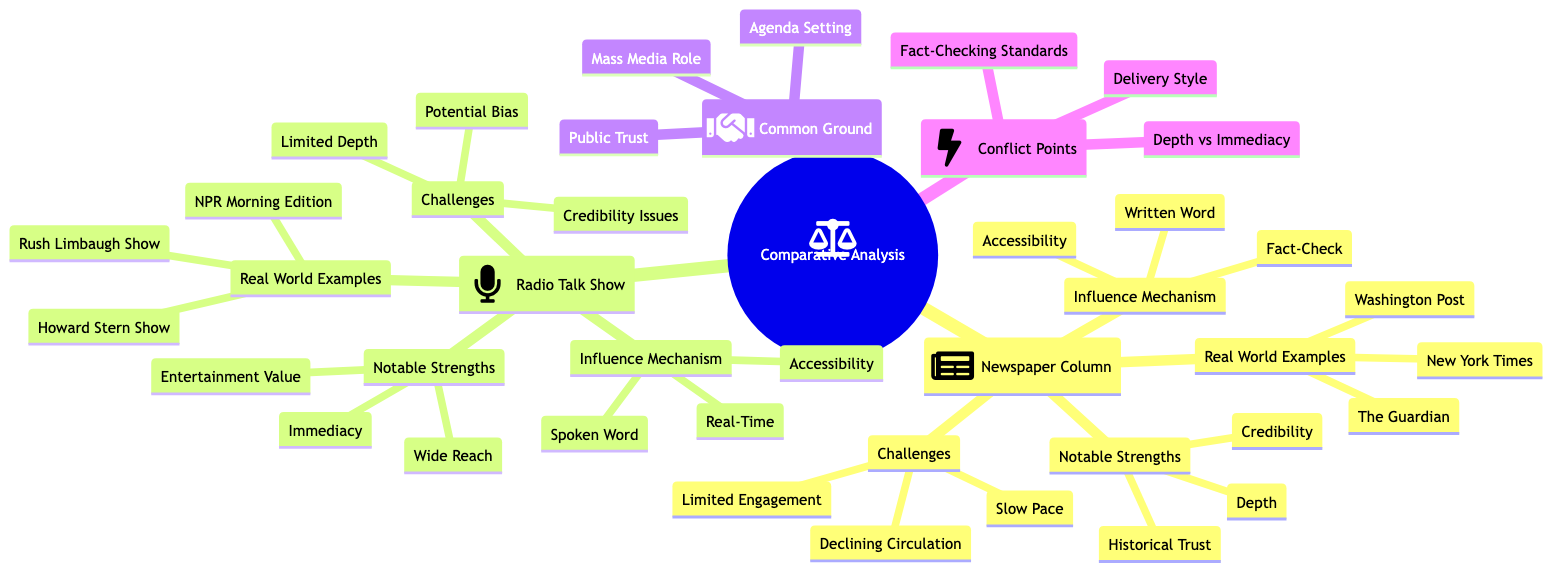What are the notable strengths of the Newspaper Column? The diagram lists three notable strengths under the Newspaper Column section: Depth, Credibility, and Historical Trust.
Answer: Depth, Credibility, Historical Trust Which radio talk show is mentioned as influential in shaping conservative public opinion? The diagram specifically identifies the Rush Limbaugh Show as influential in shaping conservative public opinion under the Real World Examples for Radio Talk Show.
Answer: Rush Limbaugh Show What is a common ground shared by both media forms? The diagram includes three points under Common Ground, one of which is Public Trust, showing that both media rely on maintaining or building public trust.
Answer: Public Trust How does the influence mechanism of the Newspaper Column compare to that of the Radio Talk Show? The Newspaper Column is characterized by Written Word, Fact-Check, and Accessibility, whereas the Radio Talk Show is characterized by Spoken Word, Real-Time, and Accessibility. Both highlight their accessibility, but differ in their other influence mechanisms.
Answer: Different mechanisms What challenges does the Radio Talk Show face compared to the Newspaper Column? While both media face challenges, the Radio Talk Show has issues with Credibility, Potential Bias, and Limited Depth, contrasting with the Newspaper Column's challenges of Slow Pace, Declining Circulation, and Limited Engagement.
Answer: Credibility, Potential Bias, Limited Depth What is the relationship between Delivery Style and the engagement levels of the two mediums? The diagram establishes a conflict point regarding Delivery Style, indicating that print (newspaper) versus spoken word (radio) can lead to different engagement levels, which highlights how the format affects audience interaction.
Answer: Different engagement levels How many real-world examples are provided for the Newspaper Column? The diagram lists three real-world examples under the Newspaper Column section: New York Times, Washington Post, and The Guardian.
Answer: Three What concept highlights the difference in analytical depth between newspapers and radio? The diagram presents Depth vs Immediacy as a conflict point, illustrating that newspapers offer more analytical depth while radio emphasizes immediacy.
Answer: Depth vs Immediacy Which method of verification is more stringent, according to the diagram? The diagram points out that the Newspaper Column is characterized by Higher journalistic standards and editorial oversight under Fact-Check, while noting issues with credibility in the Radio Talk Show section.
Answer: Higher journalistic standards 